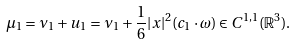Convert formula to latex. <formula><loc_0><loc_0><loc_500><loc_500>\mu _ { 1 } = \nu _ { 1 } + u _ { 1 } = \nu _ { 1 } + \frac { 1 } { 6 } | x | ^ { 2 } ( c _ { 1 } \cdot \omega ) \in C ^ { 1 , 1 } ( \mathbb { R } ^ { 3 } ) .</formula> 